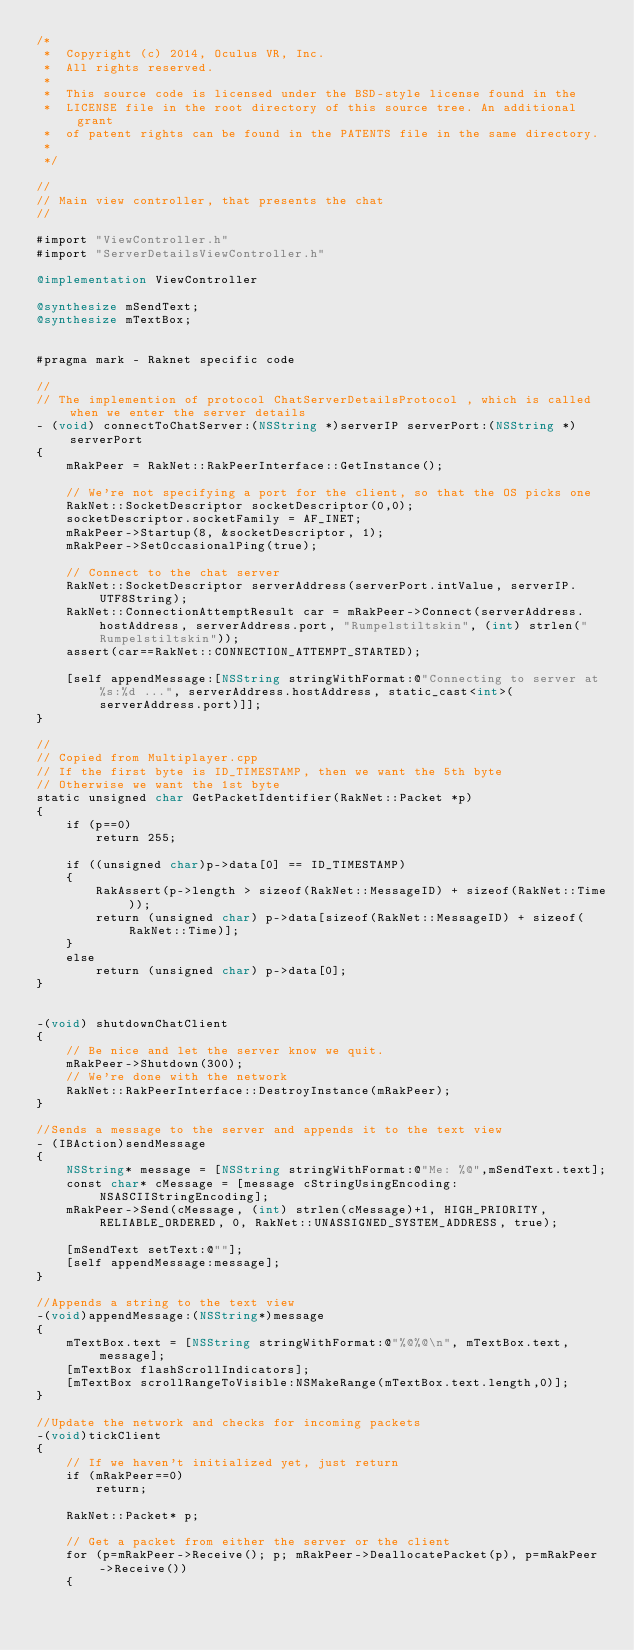Convert code to text. <code><loc_0><loc_0><loc_500><loc_500><_ObjectiveC_>/*
 *  Copyright (c) 2014, Oculus VR, Inc.
 *  All rights reserved.
 *
 *  This source code is licensed under the BSD-style license found in the
 *  LICENSE file in the root directory of this source tree. An additional grant 
 *  of patent rights can be found in the PATENTS file in the same directory.
 *
 */

//
// Main view controller, that presents the chat
//

#import "ViewController.h"
#import "ServerDetailsViewController.h"

@implementation ViewController

@synthesize mSendText;
@synthesize mTextBox;


#pragma mark - Raknet specific code

//
// The implemention of protocol ChatServerDetailsProtocol , which is called when we enter the server details
- (void) connectToChatServer:(NSString *)serverIP serverPort:(NSString *)serverPort
{
	mRakPeer = RakNet::RakPeerInterface::GetInstance();
    
    // We're not specifying a port for the client, so that the OS picks one
    RakNet::SocketDescriptor socketDescriptor(0,0);
    socketDescriptor.socketFamily = AF_INET;
    mRakPeer->Startup(8, &socketDescriptor, 1);
    mRakPeer->SetOccasionalPing(true);

    // Connect to the chat server
	RakNet::SocketDescriptor serverAddress(serverPort.intValue, serverIP.UTF8String);
    RakNet::ConnectionAttemptResult car = mRakPeer->Connect(serverAddress.hostAddress, serverAddress.port, "Rumpelstiltskin", (int) strlen("Rumpelstiltskin"));
	assert(car==RakNet::CONNECTION_ATTEMPT_STARTED);
	
	[self appendMessage:[NSString stringWithFormat:@"Connecting to server at %s:%d ...", serverAddress.hostAddress, static_cast<int>(serverAddress.port)]];
}

//
// Copied from Multiplayer.cpp
// If the first byte is ID_TIMESTAMP, then we want the 5th byte
// Otherwise we want the 1st byte
static unsigned char GetPacketIdentifier(RakNet::Packet *p)
{
	if (p==0)
		return 255;
    
	if ((unsigned char)p->data[0] == ID_TIMESTAMP)
	{
		RakAssert(p->length > sizeof(RakNet::MessageID) + sizeof(RakNet::Time));
		return (unsigned char) p->data[sizeof(RakNet::MessageID) + sizeof(RakNet::Time)];
	}
	else
		return (unsigned char) p->data[0];
}


-(void) shutdownChatClient
{
    // Be nice and let the server know we quit.
    mRakPeer->Shutdown(300);
    // We're done with the network
	RakNet::RakPeerInterface::DestroyInstance(mRakPeer);
}

//Sends a message to the server and appends it to the text view
- (IBAction)sendMessage
{
	NSString* message = [NSString stringWithFormat:@"Me: %@",mSendText.text];
	const char* cMessage = [message cStringUsingEncoding:NSASCIIStringEncoding];
	mRakPeer->Send(cMessage, (int) strlen(cMessage)+1, HIGH_PRIORITY, RELIABLE_ORDERED, 0, RakNet::UNASSIGNED_SYSTEM_ADDRESS, true);
    
	[mSendText setText:@""];
	[self appendMessage:message];
}

//Appends a string to the text view
-(void)appendMessage:(NSString*)message
{
	mTextBox.text = [NSString stringWithFormat:@"%@%@\n", mTextBox.text,message];
	[mTextBox flashScrollIndicators];
	[mTextBox scrollRangeToVisible:NSMakeRange(mTextBox.text.length,0)];
}

//Update the network and checks for incoming packets
-(void)tickClient
{
	// If we haven't initialized yet, just return
    if (mRakPeer==0)
		return;
	
    RakNet::Packet* p;
    
    // Get a packet from either the server or the client
    for (p=mRakPeer->Receive(); p; mRakPeer->DeallocatePacket(p), p=mRakPeer->Receive())
    {</code> 